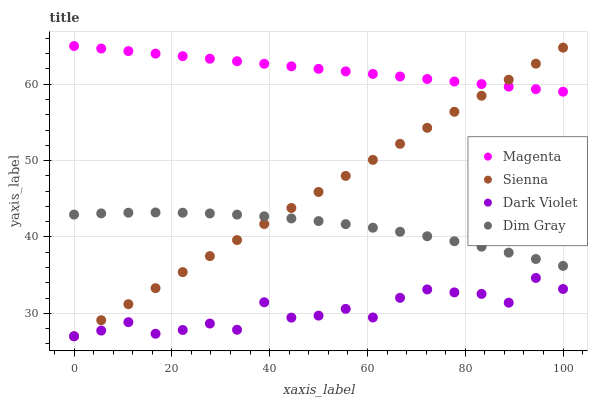Does Dark Violet have the minimum area under the curve?
Answer yes or no. Yes. Does Magenta have the maximum area under the curve?
Answer yes or no. Yes. Does Dim Gray have the minimum area under the curve?
Answer yes or no. No. Does Dim Gray have the maximum area under the curve?
Answer yes or no. No. Is Magenta the smoothest?
Answer yes or no. Yes. Is Dark Violet the roughest?
Answer yes or no. Yes. Is Dim Gray the smoothest?
Answer yes or no. No. Is Dim Gray the roughest?
Answer yes or no. No. Does Sienna have the lowest value?
Answer yes or no. Yes. Does Dim Gray have the lowest value?
Answer yes or no. No. Does Magenta have the highest value?
Answer yes or no. Yes. Does Dim Gray have the highest value?
Answer yes or no. No. Is Dim Gray less than Magenta?
Answer yes or no. Yes. Is Magenta greater than Dark Violet?
Answer yes or no. Yes. Does Dim Gray intersect Sienna?
Answer yes or no. Yes. Is Dim Gray less than Sienna?
Answer yes or no. No. Is Dim Gray greater than Sienna?
Answer yes or no. No. Does Dim Gray intersect Magenta?
Answer yes or no. No. 